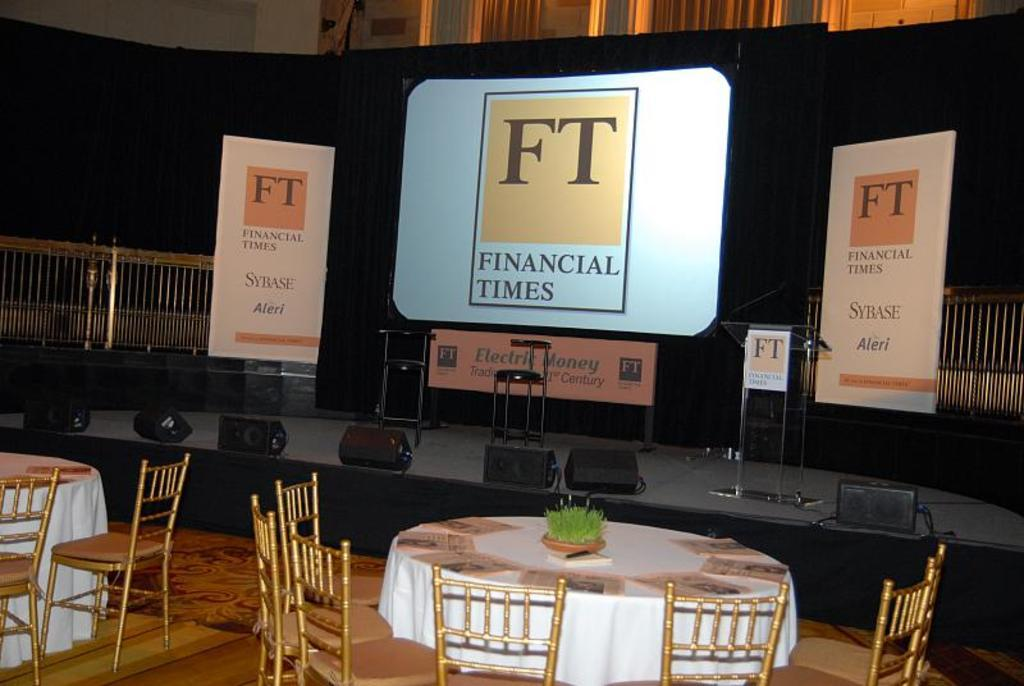<image>
Render a clear and concise summary of the photo. a presentation board that says 'financial times' on it 